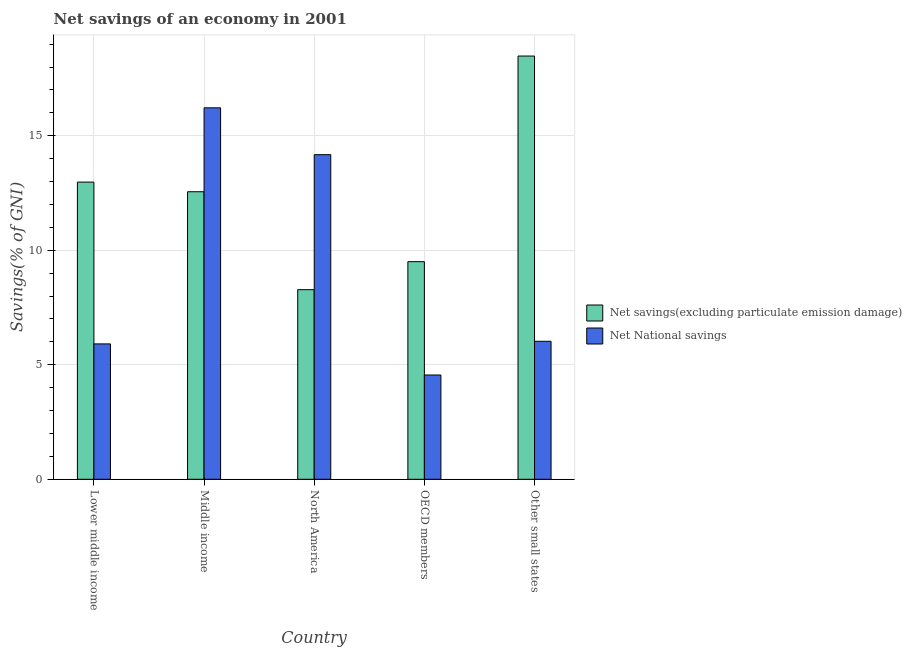How many different coloured bars are there?
Your answer should be compact. 2. How many groups of bars are there?
Provide a succinct answer. 5. Are the number of bars on each tick of the X-axis equal?
Give a very brief answer. Yes. How many bars are there on the 1st tick from the left?
Give a very brief answer. 2. How many bars are there on the 1st tick from the right?
Give a very brief answer. 2. What is the label of the 1st group of bars from the left?
Ensure brevity in your answer.  Lower middle income. In how many cases, is the number of bars for a given country not equal to the number of legend labels?
Your answer should be compact. 0. What is the net national savings in Middle income?
Give a very brief answer. 16.22. Across all countries, what is the maximum net national savings?
Your answer should be very brief. 16.22. Across all countries, what is the minimum net savings(excluding particulate emission damage)?
Make the answer very short. 8.28. In which country was the net national savings maximum?
Ensure brevity in your answer.  Middle income. In which country was the net savings(excluding particulate emission damage) minimum?
Offer a very short reply. North America. What is the total net national savings in the graph?
Ensure brevity in your answer.  46.88. What is the difference between the net savings(excluding particulate emission damage) in Lower middle income and that in North America?
Ensure brevity in your answer.  4.7. What is the difference between the net savings(excluding particulate emission damage) in Lower middle income and the net national savings in OECD members?
Ensure brevity in your answer.  8.42. What is the average net national savings per country?
Provide a short and direct response. 9.38. What is the difference between the net national savings and net savings(excluding particulate emission damage) in North America?
Provide a succinct answer. 5.89. What is the ratio of the net savings(excluding particulate emission damage) in OECD members to that in Other small states?
Your answer should be compact. 0.51. Is the difference between the net savings(excluding particulate emission damage) in Lower middle income and Middle income greater than the difference between the net national savings in Lower middle income and Middle income?
Keep it short and to the point. Yes. What is the difference between the highest and the second highest net national savings?
Provide a short and direct response. 2.05. What is the difference between the highest and the lowest net savings(excluding particulate emission damage)?
Keep it short and to the point. 10.2. In how many countries, is the net savings(excluding particulate emission damage) greater than the average net savings(excluding particulate emission damage) taken over all countries?
Your answer should be compact. 3. Is the sum of the net national savings in Middle income and OECD members greater than the maximum net savings(excluding particulate emission damage) across all countries?
Make the answer very short. Yes. What does the 2nd bar from the left in Other small states represents?
Your answer should be very brief. Net National savings. What does the 2nd bar from the right in OECD members represents?
Your answer should be very brief. Net savings(excluding particulate emission damage). How many bars are there?
Give a very brief answer. 10. Are all the bars in the graph horizontal?
Your answer should be compact. No. Are the values on the major ticks of Y-axis written in scientific E-notation?
Offer a very short reply. No. Does the graph contain any zero values?
Give a very brief answer. No. What is the title of the graph?
Offer a terse response. Net savings of an economy in 2001. What is the label or title of the Y-axis?
Provide a short and direct response. Savings(% of GNI). What is the Savings(% of GNI) of Net savings(excluding particulate emission damage) in Lower middle income?
Your answer should be compact. 12.98. What is the Savings(% of GNI) of Net National savings in Lower middle income?
Provide a succinct answer. 5.91. What is the Savings(% of GNI) in Net savings(excluding particulate emission damage) in Middle income?
Offer a very short reply. 12.55. What is the Savings(% of GNI) of Net National savings in Middle income?
Give a very brief answer. 16.22. What is the Savings(% of GNI) in Net savings(excluding particulate emission damage) in North America?
Keep it short and to the point. 8.28. What is the Savings(% of GNI) of Net National savings in North America?
Your answer should be very brief. 14.17. What is the Savings(% of GNI) in Net savings(excluding particulate emission damage) in OECD members?
Your answer should be compact. 9.5. What is the Savings(% of GNI) in Net National savings in OECD members?
Give a very brief answer. 4.55. What is the Savings(% of GNI) in Net savings(excluding particulate emission damage) in Other small states?
Your answer should be compact. 18.48. What is the Savings(% of GNI) of Net National savings in Other small states?
Your answer should be very brief. 6.03. Across all countries, what is the maximum Savings(% of GNI) of Net savings(excluding particulate emission damage)?
Ensure brevity in your answer.  18.48. Across all countries, what is the maximum Savings(% of GNI) in Net National savings?
Your answer should be compact. 16.22. Across all countries, what is the minimum Savings(% of GNI) in Net savings(excluding particulate emission damage)?
Provide a short and direct response. 8.28. Across all countries, what is the minimum Savings(% of GNI) in Net National savings?
Provide a short and direct response. 4.55. What is the total Savings(% of GNI) in Net savings(excluding particulate emission damage) in the graph?
Your response must be concise. 61.79. What is the total Savings(% of GNI) of Net National savings in the graph?
Your response must be concise. 46.88. What is the difference between the Savings(% of GNI) in Net savings(excluding particulate emission damage) in Lower middle income and that in Middle income?
Provide a succinct answer. 0.42. What is the difference between the Savings(% of GNI) of Net National savings in Lower middle income and that in Middle income?
Keep it short and to the point. -10.31. What is the difference between the Savings(% of GNI) in Net savings(excluding particulate emission damage) in Lower middle income and that in North America?
Provide a short and direct response. 4.7. What is the difference between the Savings(% of GNI) of Net National savings in Lower middle income and that in North America?
Ensure brevity in your answer.  -8.26. What is the difference between the Savings(% of GNI) of Net savings(excluding particulate emission damage) in Lower middle income and that in OECD members?
Ensure brevity in your answer.  3.47. What is the difference between the Savings(% of GNI) of Net National savings in Lower middle income and that in OECD members?
Offer a very short reply. 1.36. What is the difference between the Savings(% of GNI) in Net savings(excluding particulate emission damage) in Lower middle income and that in Other small states?
Your answer should be very brief. -5.5. What is the difference between the Savings(% of GNI) of Net National savings in Lower middle income and that in Other small states?
Ensure brevity in your answer.  -0.11. What is the difference between the Savings(% of GNI) of Net savings(excluding particulate emission damage) in Middle income and that in North America?
Keep it short and to the point. 4.28. What is the difference between the Savings(% of GNI) of Net National savings in Middle income and that in North America?
Your answer should be very brief. 2.05. What is the difference between the Savings(% of GNI) in Net savings(excluding particulate emission damage) in Middle income and that in OECD members?
Keep it short and to the point. 3.05. What is the difference between the Savings(% of GNI) in Net National savings in Middle income and that in OECD members?
Your answer should be very brief. 11.66. What is the difference between the Savings(% of GNI) in Net savings(excluding particulate emission damage) in Middle income and that in Other small states?
Provide a short and direct response. -5.92. What is the difference between the Savings(% of GNI) in Net National savings in Middle income and that in Other small states?
Your response must be concise. 10.19. What is the difference between the Savings(% of GNI) in Net savings(excluding particulate emission damage) in North America and that in OECD members?
Ensure brevity in your answer.  -1.22. What is the difference between the Savings(% of GNI) in Net National savings in North America and that in OECD members?
Offer a very short reply. 9.62. What is the difference between the Savings(% of GNI) in Net savings(excluding particulate emission damage) in North America and that in Other small states?
Your response must be concise. -10.2. What is the difference between the Savings(% of GNI) in Net National savings in North America and that in Other small states?
Your response must be concise. 8.15. What is the difference between the Savings(% of GNI) of Net savings(excluding particulate emission damage) in OECD members and that in Other small states?
Keep it short and to the point. -8.98. What is the difference between the Savings(% of GNI) in Net National savings in OECD members and that in Other small states?
Give a very brief answer. -1.47. What is the difference between the Savings(% of GNI) of Net savings(excluding particulate emission damage) in Lower middle income and the Savings(% of GNI) of Net National savings in Middle income?
Offer a very short reply. -3.24. What is the difference between the Savings(% of GNI) of Net savings(excluding particulate emission damage) in Lower middle income and the Savings(% of GNI) of Net National savings in North America?
Provide a short and direct response. -1.2. What is the difference between the Savings(% of GNI) of Net savings(excluding particulate emission damage) in Lower middle income and the Savings(% of GNI) of Net National savings in OECD members?
Give a very brief answer. 8.42. What is the difference between the Savings(% of GNI) of Net savings(excluding particulate emission damage) in Lower middle income and the Savings(% of GNI) of Net National savings in Other small states?
Provide a short and direct response. 6.95. What is the difference between the Savings(% of GNI) of Net savings(excluding particulate emission damage) in Middle income and the Savings(% of GNI) of Net National savings in North America?
Ensure brevity in your answer.  -1.62. What is the difference between the Savings(% of GNI) in Net savings(excluding particulate emission damage) in Middle income and the Savings(% of GNI) in Net National savings in OECD members?
Offer a very short reply. 8. What is the difference between the Savings(% of GNI) in Net savings(excluding particulate emission damage) in Middle income and the Savings(% of GNI) in Net National savings in Other small states?
Give a very brief answer. 6.53. What is the difference between the Savings(% of GNI) in Net savings(excluding particulate emission damage) in North America and the Savings(% of GNI) in Net National savings in OECD members?
Provide a short and direct response. 3.72. What is the difference between the Savings(% of GNI) of Net savings(excluding particulate emission damage) in North America and the Savings(% of GNI) of Net National savings in Other small states?
Your answer should be very brief. 2.25. What is the difference between the Savings(% of GNI) of Net savings(excluding particulate emission damage) in OECD members and the Savings(% of GNI) of Net National savings in Other small states?
Your answer should be very brief. 3.48. What is the average Savings(% of GNI) of Net savings(excluding particulate emission damage) per country?
Your response must be concise. 12.36. What is the average Savings(% of GNI) in Net National savings per country?
Ensure brevity in your answer.  9.38. What is the difference between the Savings(% of GNI) in Net savings(excluding particulate emission damage) and Savings(% of GNI) in Net National savings in Lower middle income?
Offer a terse response. 7.06. What is the difference between the Savings(% of GNI) in Net savings(excluding particulate emission damage) and Savings(% of GNI) in Net National savings in Middle income?
Your response must be concise. -3.66. What is the difference between the Savings(% of GNI) in Net savings(excluding particulate emission damage) and Savings(% of GNI) in Net National savings in North America?
Provide a succinct answer. -5.89. What is the difference between the Savings(% of GNI) in Net savings(excluding particulate emission damage) and Savings(% of GNI) in Net National savings in OECD members?
Provide a succinct answer. 4.95. What is the difference between the Savings(% of GNI) of Net savings(excluding particulate emission damage) and Savings(% of GNI) of Net National savings in Other small states?
Ensure brevity in your answer.  12.45. What is the ratio of the Savings(% of GNI) in Net savings(excluding particulate emission damage) in Lower middle income to that in Middle income?
Your answer should be compact. 1.03. What is the ratio of the Savings(% of GNI) of Net National savings in Lower middle income to that in Middle income?
Provide a succinct answer. 0.36. What is the ratio of the Savings(% of GNI) of Net savings(excluding particulate emission damage) in Lower middle income to that in North America?
Give a very brief answer. 1.57. What is the ratio of the Savings(% of GNI) in Net National savings in Lower middle income to that in North America?
Offer a very short reply. 0.42. What is the ratio of the Savings(% of GNI) of Net savings(excluding particulate emission damage) in Lower middle income to that in OECD members?
Offer a terse response. 1.37. What is the ratio of the Savings(% of GNI) in Net National savings in Lower middle income to that in OECD members?
Your answer should be very brief. 1.3. What is the ratio of the Savings(% of GNI) in Net savings(excluding particulate emission damage) in Lower middle income to that in Other small states?
Keep it short and to the point. 0.7. What is the ratio of the Savings(% of GNI) in Net savings(excluding particulate emission damage) in Middle income to that in North America?
Ensure brevity in your answer.  1.52. What is the ratio of the Savings(% of GNI) in Net National savings in Middle income to that in North America?
Provide a short and direct response. 1.14. What is the ratio of the Savings(% of GNI) of Net savings(excluding particulate emission damage) in Middle income to that in OECD members?
Make the answer very short. 1.32. What is the ratio of the Savings(% of GNI) of Net National savings in Middle income to that in OECD members?
Offer a terse response. 3.56. What is the ratio of the Savings(% of GNI) in Net savings(excluding particulate emission damage) in Middle income to that in Other small states?
Offer a terse response. 0.68. What is the ratio of the Savings(% of GNI) in Net National savings in Middle income to that in Other small states?
Offer a very short reply. 2.69. What is the ratio of the Savings(% of GNI) of Net savings(excluding particulate emission damage) in North America to that in OECD members?
Keep it short and to the point. 0.87. What is the ratio of the Savings(% of GNI) of Net National savings in North America to that in OECD members?
Your answer should be very brief. 3.11. What is the ratio of the Savings(% of GNI) in Net savings(excluding particulate emission damage) in North America to that in Other small states?
Your answer should be compact. 0.45. What is the ratio of the Savings(% of GNI) of Net National savings in North America to that in Other small states?
Your response must be concise. 2.35. What is the ratio of the Savings(% of GNI) of Net savings(excluding particulate emission damage) in OECD members to that in Other small states?
Provide a short and direct response. 0.51. What is the ratio of the Savings(% of GNI) in Net National savings in OECD members to that in Other small states?
Offer a very short reply. 0.76. What is the difference between the highest and the second highest Savings(% of GNI) in Net savings(excluding particulate emission damage)?
Provide a short and direct response. 5.5. What is the difference between the highest and the second highest Savings(% of GNI) in Net National savings?
Provide a succinct answer. 2.05. What is the difference between the highest and the lowest Savings(% of GNI) of Net savings(excluding particulate emission damage)?
Keep it short and to the point. 10.2. What is the difference between the highest and the lowest Savings(% of GNI) of Net National savings?
Your response must be concise. 11.66. 